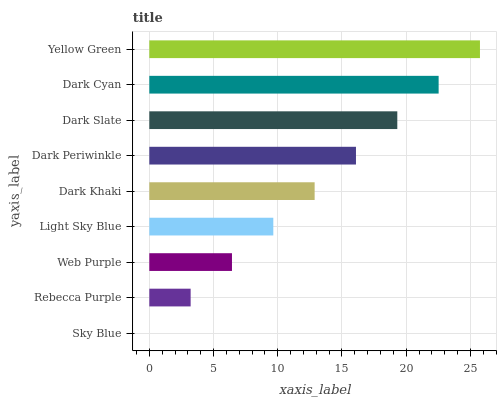Is Sky Blue the minimum?
Answer yes or no. Yes. Is Yellow Green the maximum?
Answer yes or no. Yes. Is Rebecca Purple the minimum?
Answer yes or no. No. Is Rebecca Purple the maximum?
Answer yes or no. No. Is Rebecca Purple greater than Sky Blue?
Answer yes or no. Yes. Is Sky Blue less than Rebecca Purple?
Answer yes or no. Yes. Is Sky Blue greater than Rebecca Purple?
Answer yes or no. No. Is Rebecca Purple less than Sky Blue?
Answer yes or no. No. Is Dark Khaki the high median?
Answer yes or no. Yes. Is Dark Khaki the low median?
Answer yes or no. Yes. Is Yellow Green the high median?
Answer yes or no. No. Is Dark Periwinkle the low median?
Answer yes or no. No. 